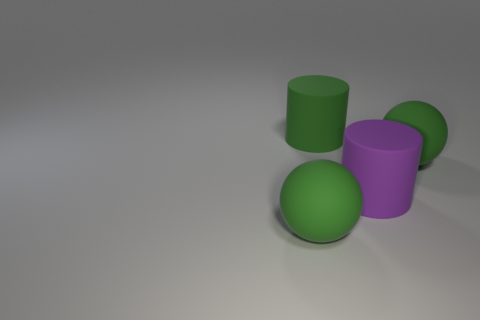Add 2 green cylinders. How many objects exist? 6 Add 1 purple matte things. How many purple matte things are left? 2 Add 3 purple matte cylinders. How many purple matte cylinders exist? 4 Subtract 1 purple cylinders. How many objects are left? 3 Subtract all spheres. Subtract all green rubber cylinders. How many objects are left? 1 